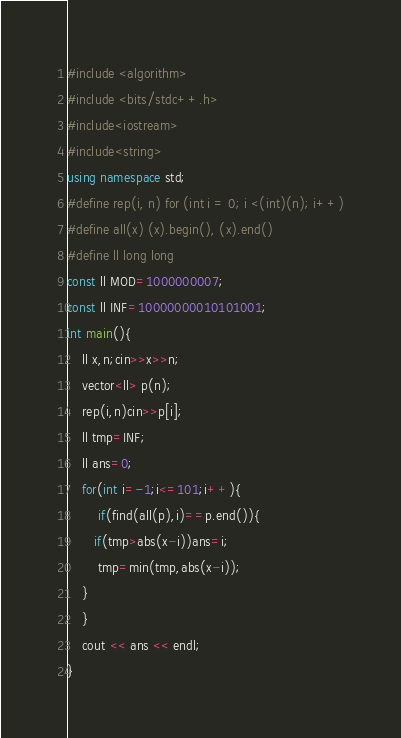Convert code to text. <code><loc_0><loc_0><loc_500><loc_500><_C++_>#include <algorithm>
#include <bits/stdc++.h>
#include<iostream>
#include<string>
using namespace std;
#define rep(i, n) for (int i = 0; i <(int)(n); i++)
#define all(x) (x).begin(), (x).end()
#define ll long long
const ll MOD=1000000007;
const ll INF=10000000010101001;
int main(){
    ll x,n;cin>>x>>n;
    vector<ll> p(n);
    rep(i,n)cin>>p[i];
    ll tmp=INF;
    ll ans=0;
    for(int i=-1;i<=101;i++){
        if(find(all(p),i)==p.end()){
       if(tmp>abs(x-i))ans=i;
        tmp=min(tmp,abs(x-i));
    }
    }
    cout << ans << endl;
}</code> 